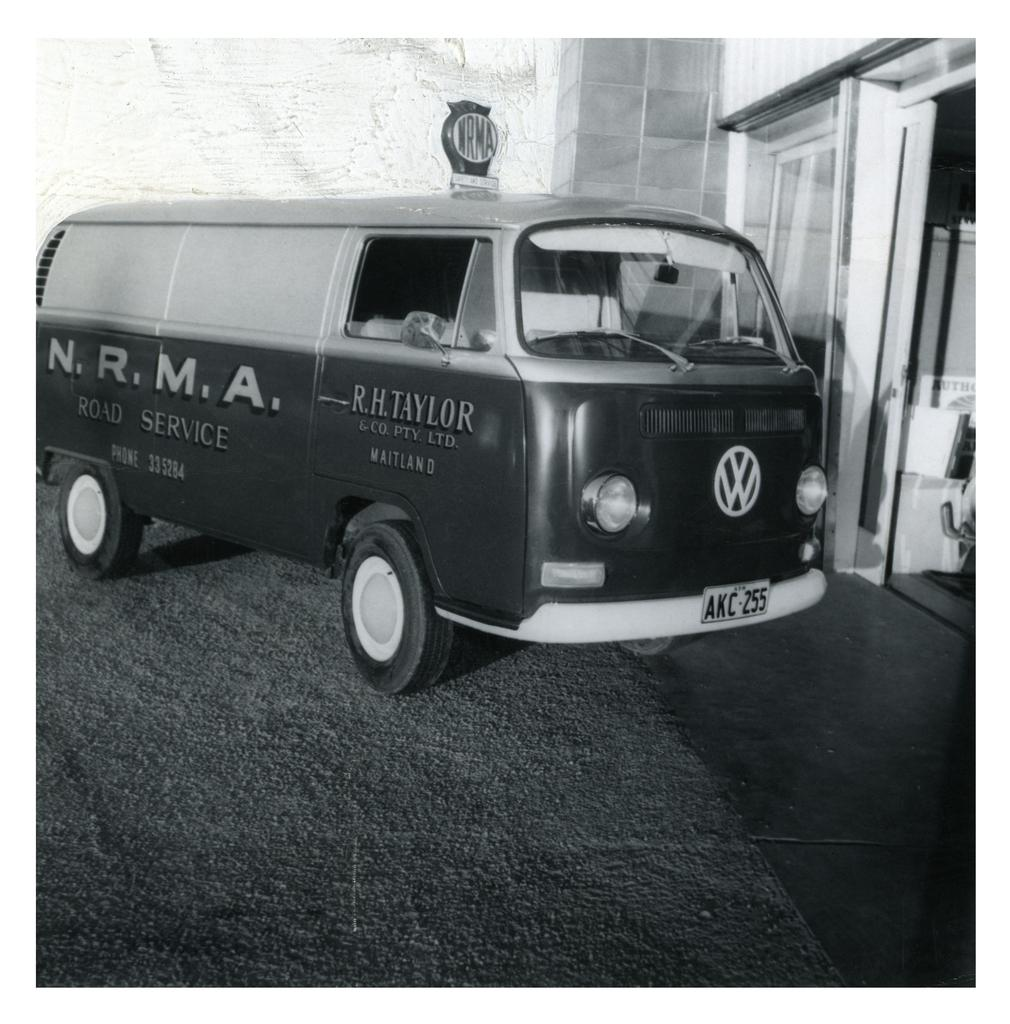Provide a one-sentence caption for the provided image. the vintage model van which has a writing in side as N.R.M.A road service. 